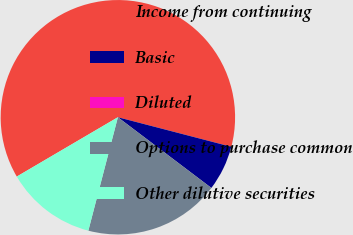Convert chart. <chart><loc_0><loc_0><loc_500><loc_500><pie_chart><fcel>Income from continuing<fcel>Basic<fcel>Diluted<fcel>Options to purchase common<fcel>Other dilutive securities<nl><fcel>62.5%<fcel>6.25%<fcel>0.0%<fcel>18.75%<fcel>12.5%<nl></chart> 